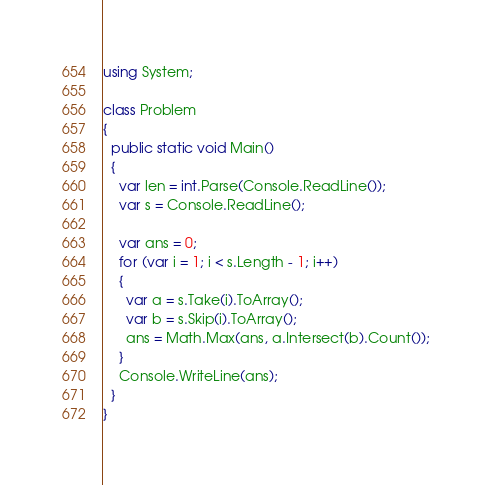<code> <loc_0><loc_0><loc_500><loc_500><_C#_>using System;

class Problem
{
  public static void Main()
  {
    var len = int.Parse(Console.ReadLine());
    var s = Console.ReadLine();

    var ans = 0;
    for (var i = 1; i < s.Length - 1; i++)
    {
      var a = s.Take(i).ToArray();
      var b = s.Skip(i).ToArray();
      ans = Math.Max(ans, a.Intersect(b).Count());
    }
    Console.WriteLine(ans);
  }
}
</code> 